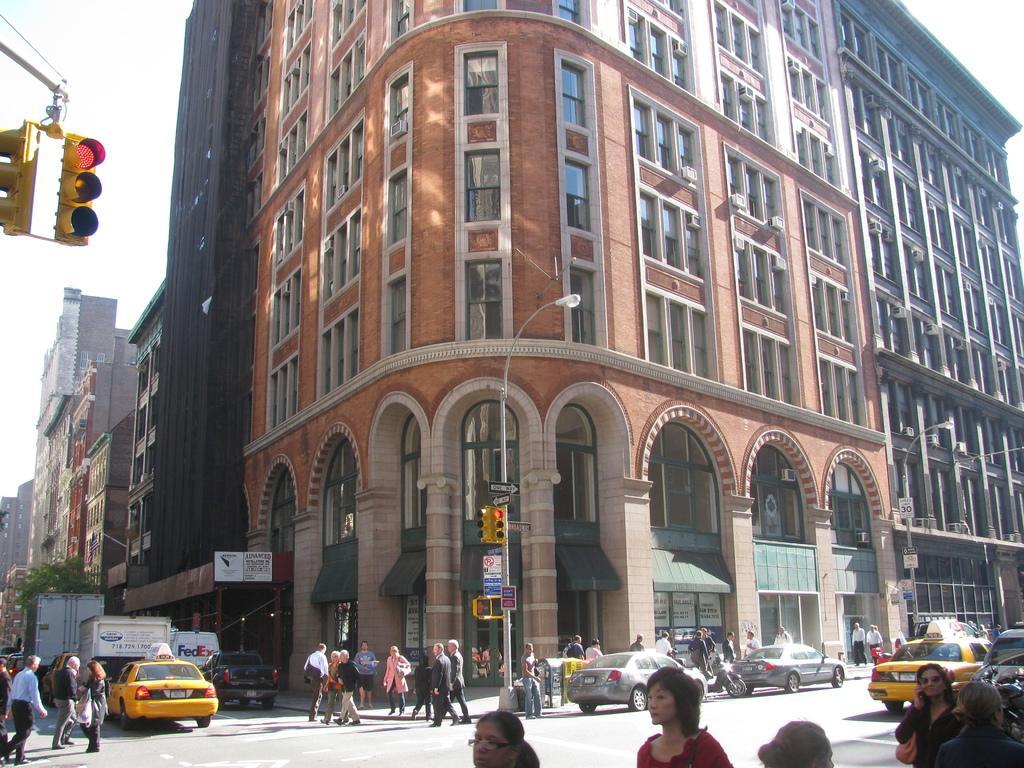Describe this image in one or two sentences. At the bottom of the image there is a road and we can see cars on the road. There are many people walking and standing. In the background there are buildings. In the center we can see a pole and a traffic light. On the left there is a tree. At the top there is sky. 